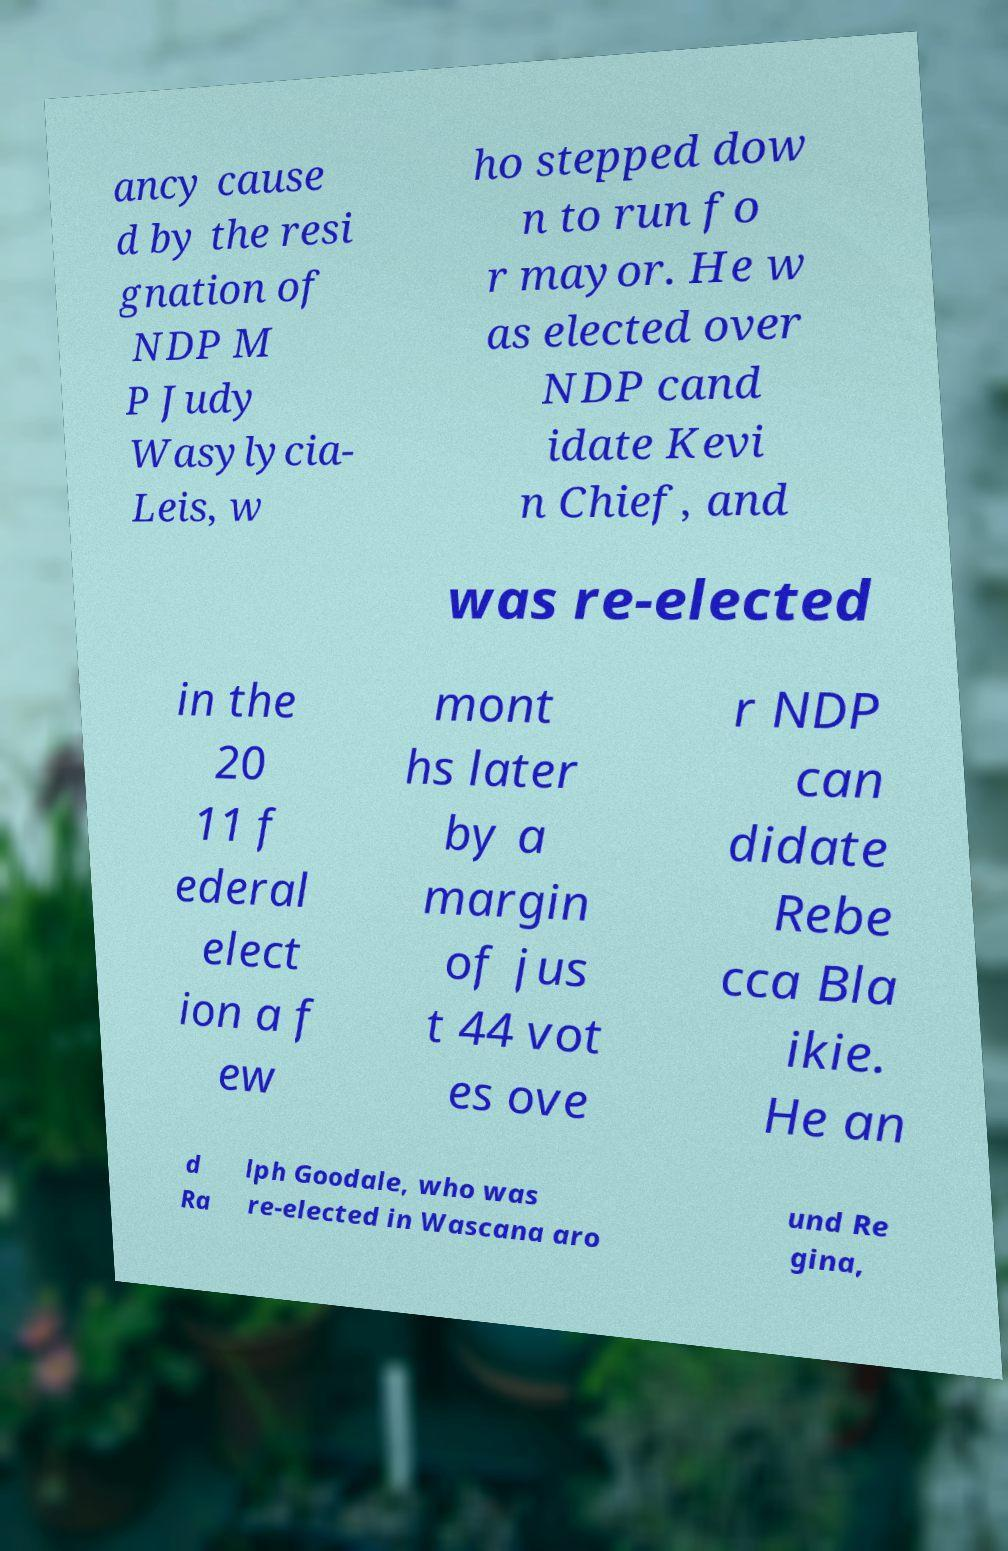Could you assist in decoding the text presented in this image and type it out clearly? ancy cause d by the resi gnation of NDP M P Judy Wasylycia- Leis, w ho stepped dow n to run fo r mayor. He w as elected over NDP cand idate Kevi n Chief, and was re-elected in the 20 11 f ederal elect ion a f ew mont hs later by a margin of jus t 44 vot es ove r NDP can didate Rebe cca Bla ikie. He an d Ra lph Goodale, who was re-elected in Wascana aro und Re gina, 